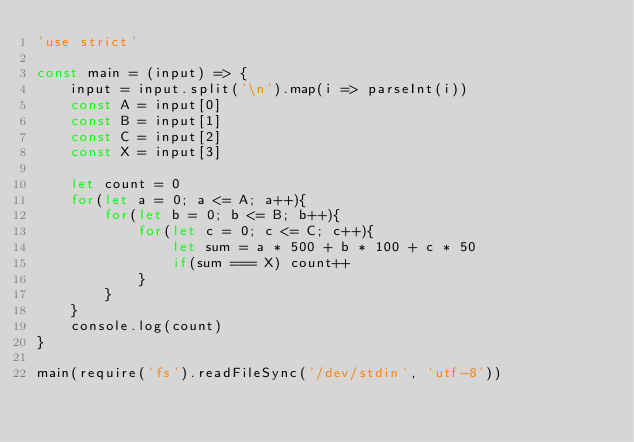<code> <loc_0><loc_0><loc_500><loc_500><_JavaScript_>'use strict'

const main = (input) => {
    input = input.split('\n').map(i => parseInt(i))
    const A = input[0]
    const B = input[1]
    const C = input[2]
    const X = input[3]

    let count = 0
    for(let a = 0; a <= A; a++){
        for(let b = 0; b <= B; b++){
            for(let c = 0; c <= C; c++){
                let sum = a * 500 + b * 100 + c * 50
                if(sum === X) count++
            }
        }
    }
    console.log(count)
}

main(require('fs').readFileSync('/dev/stdin', 'utf-8'))</code> 